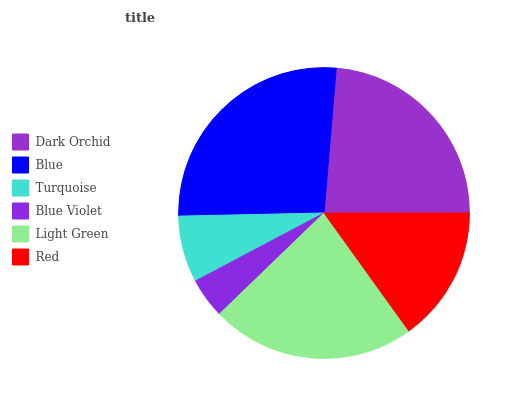Is Blue Violet the minimum?
Answer yes or no. Yes. Is Blue the maximum?
Answer yes or no. Yes. Is Turquoise the minimum?
Answer yes or no. No. Is Turquoise the maximum?
Answer yes or no. No. Is Blue greater than Turquoise?
Answer yes or no. Yes. Is Turquoise less than Blue?
Answer yes or no. Yes. Is Turquoise greater than Blue?
Answer yes or no. No. Is Blue less than Turquoise?
Answer yes or no. No. Is Light Green the high median?
Answer yes or no. Yes. Is Red the low median?
Answer yes or no. Yes. Is Blue Violet the high median?
Answer yes or no. No. Is Blue the low median?
Answer yes or no. No. 